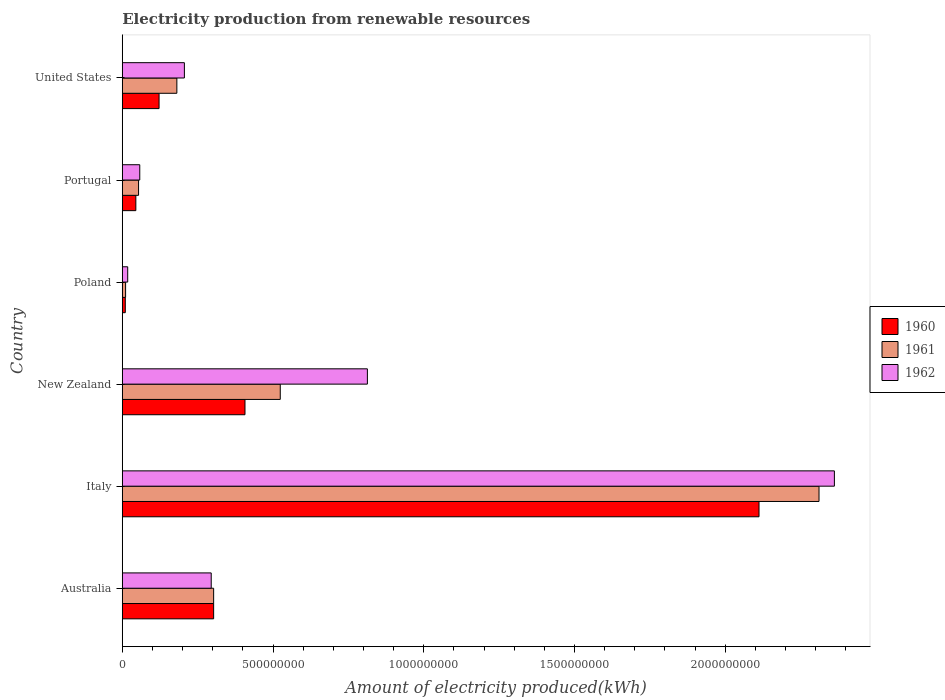How many bars are there on the 5th tick from the top?
Ensure brevity in your answer.  3. How many bars are there on the 4th tick from the bottom?
Provide a succinct answer. 3. Across all countries, what is the maximum amount of electricity produced in 1961?
Your answer should be very brief. 2.31e+09. Across all countries, what is the minimum amount of electricity produced in 1960?
Your answer should be compact. 1.00e+07. In which country was the amount of electricity produced in 1960 maximum?
Provide a succinct answer. Italy. What is the total amount of electricity produced in 1961 in the graph?
Your answer should be very brief. 3.38e+09. What is the difference between the amount of electricity produced in 1962 in Italy and that in New Zealand?
Give a very brief answer. 1.55e+09. What is the difference between the amount of electricity produced in 1962 in Italy and the amount of electricity produced in 1961 in Portugal?
Make the answer very short. 2.31e+09. What is the average amount of electricity produced in 1962 per country?
Your answer should be compact. 6.25e+08. What is the difference between the amount of electricity produced in 1960 and amount of electricity produced in 1961 in Portugal?
Your answer should be compact. -9.00e+06. In how many countries, is the amount of electricity produced in 1962 greater than 100000000 kWh?
Ensure brevity in your answer.  4. What is the ratio of the amount of electricity produced in 1960 in Australia to that in Italy?
Give a very brief answer. 0.14. Is the amount of electricity produced in 1960 in Italy less than that in New Zealand?
Your answer should be compact. No. Is the difference between the amount of electricity produced in 1960 in Italy and Portugal greater than the difference between the amount of electricity produced in 1961 in Italy and Portugal?
Offer a very short reply. No. What is the difference between the highest and the second highest amount of electricity produced in 1960?
Keep it short and to the point. 1.70e+09. What is the difference between the highest and the lowest amount of electricity produced in 1961?
Give a very brief answer. 2.30e+09. Is the sum of the amount of electricity produced in 1960 in Australia and Italy greater than the maximum amount of electricity produced in 1961 across all countries?
Ensure brevity in your answer.  Yes. What does the 2nd bar from the top in Australia represents?
Provide a short and direct response. 1961. Is it the case that in every country, the sum of the amount of electricity produced in 1962 and amount of electricity produced in 1961 is greater than the amount of electricity produced in 1960?
Ensure brevity in your answer.  Yes. Are all the bars in the graph horizontal?
Offer a very short reply. Yes. Does the graph contain any zero values?
Provide a succinct answer. No. Where does the legend appear in the graph?
Your answer should be compact. Center right. What is the title of the graph?
Provide a short and direct response. Electricity production from renewable resources. Does "1977" appear as one of the legend labels in the graph?
Offer a very short reply. No. What is the label or title of the X-axis?
Provide a short and direct response. Amount of electricity produced(kWh). What is the Amount of electricity produced(kWh) of 1960 in Australia?
Your response must be concise. 3.03e+08. What is the Amount of electricity produced(kWh) of 1961 in Australia?
Offer a terse response. 3.03e+08. What is the Amount of electricity produced(kWh) in 1962 in Australia?
Make the answer very short. 2.95e+08. What is the Amount of electricity produced(kWh) of 1960 in Italy?
Provide a succinct answer. 2.11e+09. What is the Amount of electricity produced(kWh) in 1961 in Italy?
Give a very brief answer. 2.31e+09. What is the Amount of electricity produced(kWh) of 1962 in Italy?
Your response must be concise. 2.36e+09. What is the Amount of electricity produced(kWh) of 1960 in New Zealand?
Give a very brief answer. 4.07e+08. What is the Amount of electricity produced(kWh) in 1961 in New Zealand?
Provide a short and direct response. 5.24e+08. What is the Amount of electricity produced(kWh) of 1962 in New Zealand?
Keep it short and to the point. 8.13e+08. What is the Amount of electricity produced(kWh) of 1961 in Poland?
Give a very brief answer. 1.10e+07. What is the Amount of electricity produced(kWh) in 1962 in Poland?
Provide a short and direct response. 1.80e+07. What is the Amount of electricity produced(kWh) of 1960 in Portugal?
Your answer should be very brief. 4.50e+07. What is the Amount of electricity produced(kWh) of 1961 in Portugal?
Your response must be concise. 5.40e+07. What is the Amount of electricity produced(kWh) of 1962 in Portugal?
Your answer should be compact. 5.80e+07. What is the Amount of electricity produced(kWh) of 1960 in United States?
Make the answer very short. 1.22e+08. What is the Amount of electricity produced(kWh) of 1961 in United States?
Give a very brief answer. 1.81e+08. What is the Amount of electricity produced(kWh) of 1962 in United States?
Keep it short and to the point. 2.06e+08. Across all countries, what is the maximum Amount of electricity produced(kWh) of 1960?
Your answer should be compact. 2.11e+09. Across all countries, what is the maximum Amount of electricity produced(kWh) of 1961?
Provide a succinct answer. 2.31e+09. Across all countries, what is the maximum Amount of electricity produced(kWh) in 1962?
Give a very brief answer. 2.36e+09. Across all countries, what is the minimum Amount of electricity produced(kWh) in 1961?
Your response must be concise. 1.10e+07. Across all countries, what is the minimum Amount of electricity produced(kWh) of 1962?
Your answer should be very brief. 1.80e+07. What is the total Amount of electricity produced(kWh) in 1960 in the graph?
Give a very brief answer. 3.00e+09. What is the total Amount of electricity produced(kWh) of 1961 in the graph?
Ensure brevity in your answer.  3.38e+09. What is the total Amount of electricity produced(kWh) of 1962 in the graph?
Give a very brief answer. 3.75e+09. What is the difference between the Amount of electricity produced(kWh) of 1960 in Australia and that in Italy?
Offer a very short reply. -1.81e+09. What is the difference between the Amount of electricity produced(kWh) of 1961 in Australia and that in Italy?
Ensure brevity in your answer.  -2.01e+09. What is the difference between the Amount of electricity produced(kWh) of 1962 in Australia and that in Italy?
Your response must be concise. -2.07e+09. What is the difference between the Amount of electricity produced(kWh) in 1960 in Australia and that in New Zealand?
Keep it short and to the point. -1.04e+08. What is the difference between the Amount of electricity produced(kWh) of 1961 in Australia and that in New Zealand?
Your answer should be compact. -2.21e+08. What is the difference between the Amount of electricity produced(kWh) in 1962 in Australia and that in New Zealand?
Your answer should be compact. -5.18e+08. What is the difference between the Amount of electricity produced(kWh) of 1960 in Australia and that in Poland?
Provide a succinct answer. 2.93e+08. What is the difference between the Amount of electricity produced(kWh) of 1961 in Australia and that in Poland?
Give a very brief answer. 2.92e+08. What is the difference between the Amount of electricity produced(kWh) of 1962 in Australia and that in Poland?
Your answer should be very brief. 2.77e+08. What is the difference between the Amount of electricity produced(kWh) in 1960 in Australia and that in Portugal?
Make the answer very short. 2.58e+08. What is the difference between the Amount of electricity produced(kWh) in 1961 in Australia and that in Portugal?
Provide a succinct answer. 2.49e+08. What is the difference between the Amount of electricity produced(kWh) in 1962 in Australia and that in Portugal?
Offer a very short reply. 2.37e+08. What is the difference between the Amount of electricity produced(kWh) in 1960 in Australia and that in United States?
Your response must be concise. 1.81e+08. What is the difference between the Amount of electricity produced(kWh) in 1961 in Australia and that in United States?
Make the answer very short. 1.22e+08. What is the difference between the Amount of electricity produced(kWh) in 1962 in Australia and that in United States?
Make the answer very short. 8.90e+07. What is the difference between the Amount of electricity produced(kWh) of 1960 in Italy and that in New Zealand?
Provide a short and direct response. 1.70e+09. What is the difference between the Amount of electricity produced(kWh) of 1961 in Italy and that in New Zealand?
Provide a short and direct response. 1.79e+09. What is the difference between the Amount of electricity produced(kWh) in 1962 in Italy and that in New Zealand?
Your answer should be very brief. 1.55e+09. What is the difference between the Amount of electricity produced(kWh) in 1960 in Italy and that in Poland?
Your answer should be compact. 2.10e+09. What is the difference between the Amount of electricity produced(kWh) in 1961 in Italy and that in Poland?
Provide a short and direct response. 2.30e+09. What is the difference between the Amount of electricity produced(kWh) in 1962 in Italy and that in Poland?
Offer a very short reply. 2.34e+09. What is the difference between the Amount of electricity produced(kWh) of 1960 in Italy and that in Portugal?
Offer a very short reply. 2.07e+09. What is the difference between the Amount of electricity produced(kWh) of 1961 in Italy and that in Portugal?
Keep it short and to the point. 2.26e+09. What is the difference between the Amount of electricity produced(kWh) of 1962 in Italy and that in Portugal?
Your response must be concise. 2.30e+09. What is the difference between the Amount of electricity produced(kWh) of 1960 in Italy and that in United States?
Your response must be concise. 1.99e+09. What is the difference between the Amount of electricity produced(kWh) in 1961 in Italy and that in United States?
Offer a terse response. 2.13e+09. What is the difference between the Amount of electricity produced(kWh) of 1962 in Italy and that in United States?
Keep it short and to the point. 2.16e+09. What is the difference between the Amount of electricity produced(kWh) of 1960 in New Zealand and that in Poland?
Ensure brevity in your answer.  3.97e+08. What is the difference between the Amount of electricity produced(kWh) of 1961 in New Zealand and that in Poland?
Keep it short and to the point. 5.13e+08. What is the difference between the Amount of electricity produced(kWh) of 1962 in New Zealand and that in Poland?
Provide a short and direct response. 7.95e+08. What is the difference between the Amount of electricity produced(kWh) in 1960 in New Zealand and that in Portugal?
Your response must be concise. 3.62e+08. What is the difference between the Amount of electricity produced(kWh) of 1961 in New Zealand and that in Portugal?
Provide a succinct answer. 4.70e+08. What is the difference between the Amount of electricity produced(kWh) of 1962 in New Zealand and that in Portugal?
Your answer should be compact. 7.55e+08. What is the difference between the Amount of electricity produced(kWh) of 1960 in New Zealand and that in United States?
Your answer should be very brief. 2.85e+08. What is the difference between the Amount of electricity produced(kWh) in 1961 in New Zealand and that in United States?
Ensure brevity in your answer.  3.43e+08. What is the difference between the Amount of electricity produced(kWh) of 1962 in New Zealand and that in United States?
Offer a terse response. 6.07e+08. What is the difference between the Amount of electricity produced(kWh) of 1960 in Poland and that in Portugal?
Give a very brief answer. -3.50e+07. What is the difference between the Amount of electricity produced(kWh) in 1961 in Poland and that in Portugal?
Offer a terse response. -4.30e+07. What is the difference between the Amount of electricity produced(kWh) of 1962 in Poland and that in Portugal?
Your answer should be compact. -4.00e+07. What is the difference between the Amount of electricity produced(kWh) in 1960 in Poland and that in United States?
Ensure brevity in your answer.  -1.12e+08. What is the difference between the Amount of electricity produced(kWh) of 1961 in Poland and that in United States?
Your answer should be compact. -1.70e+08. What is the difference between the Amount of electricity produced(kWh) of 1962 in Poland and that in United States?
Provide a succinct answer. -1.88e+08. What is the difference between the Amount of electricity produced(kWh) in 1960 in Portugal and that in United States?
Give a very brief answer. -7.70e+07. What is the difference between the Amount of electricity produced(kWh) of 1961 in Portugal and that in United States?
Provide a succinct answer. -1.27e+08. What is the difference between the Amount of electricity produced(kWh) in 1962 in Portugal and that in United States?
Offer a very short reply. -1.48e+08. What is the difference between the Amount of electricity produced(kWh) in 1960 in Australia and the Amount of electricity produced(kWh) in 1961 in Italy?
Make the answer very short. -2.01e+09. What is the difference between the Amount of electricity produced(kWh) of 1960 in Australia and the Amount of electricity produced(kWh) of 1962 in Italy?
Your answer should be very brief. -2.06e+09. What is the difference between the Amount of electricity produced(kWh) of 1961 in Australia and the Amount of electricity produced(kWh) of 1962 in Italy?
Your answer should be compact. -2.06e+09. What is the difference between the Amount of electricity produced(kWh) of 1960 in Australia and the Amount of electricity produced(kWh) of 1961 in New Zealand?
Your answer should be compact. -2.21e+08. What is the difference between the Amount of electricity produced(kWh) in 1960 in Australia and the Amount of electricity produced(kWh) in 1962 in New Zealand?
Provide a short and direct response. -5.10e+08. What is the difference between the Amount of electricity produced(kWh) in 1961 in Australia and the Amount of electricity produced(kWh) in 1962 in New Zealand?
Ensure brevity in your answer.  -5.10e+08. What is the difference between the Amount of electricity produced(kWh) in 1960 in Australia and the Amount of electricity produced(kWh) in 1961 in Poland?
Give a very brief answer. 2.92e+08. What is the difference between the Amount of electricity produced(kWh) in 1960 in Australia and the Amount of electricity produced(kWh) in 1962 in Poland?
Offer a very short reply. 2.85e+08. What is the difference between the Amount of electricity produced(kWh) of 1961 in Australia and the Amount of electricity produced(kWh) of 1962 in Poland?
Provide a succinct answer. 2.85e+08. What is the difference between the Amount of electricity produced(kWh) in 1960 in Australia and the Amount of electricity produced(kWh) in 1961 in Portugal?
Keep it short and to the point. 2.49e+08. What is the difference between the Amount of electricity produced(kWh) of 1960 in Australia and the Amount of electricity produced(kWh) of 1962 in Portugal?
Your answer should be very brief. 2.45e+08. What is the difference between the Amount of electricity produced(kWh) in 1961 in Australia and the Amount of electricity produced(kWh) in 1962 in Portugal?
Offer a very short reply. 2.45e+08. What is the difference between the Amount of electricity produced(kWh) in 1960 in Australia and the Amount of electricity produced(kWh) in 1961 in United States?
Offer a terse response. 1.22e+08. What is the difference between the Amount of electricity produced(kWh) of 1960 in Australia and the Amount of electricity produced(kWh) of 1962 in United States?
Give a very brief answer. 9.70e+07. What is the difference between the Amount of electricity produced(kWh) of 1961 in Australia and the Amount of electricity produced(kWh) of 1962 in United States?
Provide a short and direct response. 9.70e+07. What is the difference between the Amount of electricity produced(kWh) of 1960 in Italy and the Amount of electricity produced(kWh) of 1961 in New Zealand?
Ensure brevity in your answer.  1.59e+09. What is the difference between the Amount of electricity produced(kWh) in 1960 in Italy and the Amount of electricity produced(kWh) in 1962 in New Zealand?
Keep it short and to the point. 1.30e+09. What is the difference between the Amount of electricity produced(kWh) of 1961 in Italy and the Amount of electricity produced(kWh) of 1962 in New Zealand?
Make the answer very short. 1.50e+09. What is the difference between the Amount of electricity produced(kWh) in 1960 in Italy and the Amount of electricity produced(kWh) in 1961 in Poland?
Your answer should be compact. 2.10e+09. What is the difference between the Amount of electricity produced(kWh) of 1960 in Italy and the Amount of electricity produced(kWh) of 1962 in Poland?
Provide a succinct answer. 2.09e+09. What is the difference between the Amount of electricity produced(kWh) of 1961 in Italy and the Amount of electricity produced(kWh) of 1962 in Poland?
Make the answer very short. 2.29e+09. What is the difference between the Amount of electricity produced(kWh) in 1960 in Italy and the Amount of electricity produced(kWh) in 1961 in Portugal?
Give a very brief answer. 2.06e+09. What is the difference between the Amount of electricity produced(kWh) of 1960 in Italy and the Amount of electricity produced(kWh) of 1962 in Portugal?
Ensure brevity in your answer.  2.05e+09. What is the difference between the Amount of electricity produced(kWh) of 1961 in Italy and the Amount of electricity produced(kWh) of 1962 in Portugal?
Your response must be concise. 2.25e+09. What is the difference between the Amount of electricity produced(kWh) of 1960 in Italy and the Amount of electricity produced(kWh) of 1961 in United States?
Give a very brief answer. 1.93e+09. What is the difference between the Amount of electricity produced(kWh) in 1960 in Italy and the Amount of electricity produced(kWh) in 1962 in United States?
Provide a succinct answer. 1.91e+09. What is the difference between the Amount of electricity produced(kWh) in 1961 in Italy and the Amount of electricity produced(kWh) in 1962 in United States?
Your response must be concise. 2.10e+09. What is the difference between the Amount of electricity produced(kWh) in 1960 in New Zealand and the Amount of electricity produced(kWh) in 1961 in Poland?
Keep it short and to the point. 3.96e+08. What is the difference between the Amount of electricity produced(kWh) in 1960 in New Zealand and the Amount of electricity produced(kWh) in 1962 in Poland?
Give a very brief answer. 3.89e+08. What is the difference between the Amount of electricity produced(kWh) of 1961 in New Zealand and the Amount of electricity produced(kWh) of 1962 in Poland?
Your answer should be very brief. 5.06e+08. What is the difference between the Amount of electricity produced(kWh) of 1960 in New Zealand and the Amount of electricity produced(kWh) of 1961 in Portugal?
Make the answer very short. 3.53e+08. What is the difference between the Amount of electricity produced(kWh) of 1960 in New Zealand and the Amount of electricity produced(kWh) of 1962 in Portugal?
Ensure brevity in your answer.  3.49e+08. What is the difference between the Amount of electricity produced(kWh) in 1961 in New Zealand and the Amount of electricity produced(kWh) in 1962 in Portugal?
Your answer should be very brief. 4.66e+08. What is the difference between the Amount of electricity produced(kWh) of 1960 in New Zealand and the Amount of electricity produced(kWh) of 1961 in United States?
Keep it short and to the point. 2.26e+08. What is the difference between the Amount of electricity produced(kWh) in 1960 in New Zealand and the Amount of electricity produced(kWh) in 1962 in United States?
Offer a very short reply. 2.01e+08. What is the difference between the Amount of electricity produced(kWh) of 1961 in New Zealand and the Amount of electricity produced(kWh) of 1962 in United States?
Offer a terse response. 3.18e+08. What is the difference between the Amount of electricity produced(kWh) in 1960 in Poland and the Amount of electricity produced(kWh) in 1961 in Portugal?
Provide a short and direct response. -4.40e+07. What is the difference between the Amount of electricity produced(kWh) in 1960 in Poland and the Amount of electricity produced(kWh) in 1962 in Portugal?
Your response must be concise. -4.80e+07. What is the difference between the Amount of electricity produced(kWh) in 1961 in Poland and the Amount of electricity produced(kWh) in 1962 in Portugal?
Your answer should be compact. -4.70e+07. What is the difference between the Amount of electricity produced(kWh) of 1960 in Poland and the Amount of electricity produced(kWh) of 1961 in United States?
Provide a succinct answer. -1.71e+08. What is the difference between the Amount of electricity produced(kWh) in 1960 in Poland and the Amount of electricity produced(kWh) in 1962 in United States?
Your answer should be compact. -1.96e+08. What is the difference between the Amount of electricity produced(kWh) in 1961 in Poland and the Amount of electricity produced(kWh) in 1962 in United States?
Keep it short and to the point. -1.95e+08. What is the difference between the Amount of electricity produced(kWh) of 1960 in Portugal and the Amount of electricity produced(kWh) of 1961 in United States?
Keep it short and to the point. -1.36e+08. What is the difference between the Amount of electricity produced(kWh) of 1960 in Portugal and the Amount of electricity produced(kWh) of 1962 in United States?
Keep it short and to the point. -1.61e+08. What is the difference between the Amount of electricity produced(kWh) of 1961 in Portugal and the Amount of electricity produced(kWh) of 1962 in United States?
Provide a succinct answer. -1.52e+08. What is the average Amount of electricity produced(kWh) in 1960 per country?
Provide a short and direct response. 5.00e+08. What is the average Amount of electricity produced(kWh) of 1961 per country?
Offer a terse response. 5.64e+08. What is the average Amount of electricity produced(kWh) in 1962 per country?
Provide a succinct answer. 6.25e+08. What is the difference between the Amount of electricity produced(kWh) of 1960 and Amount of electricity produced(kWh) of 1962 in Australia?
Offer a terse response. 8.00e+06. What is the difference between the Amount of electricity produced(kWh) in 1960 and Amount of electricity produced(kWh) in 1961 in Italy?
Offer a very short reply. -1.99e+08. What is the difference between the Amount of electricity produced(kWh) in 1960 and Amount of electricity produced(kWh) in 1962 in Italy?
Offer a very short reply. -2.50e+08. What is the difference between the Amount of electricity produced(kWh) in 1961 and Amount of electricity produced(kWh) in 1962 in Italy?
Provide a succinct answer. -5.10e+07. What is the difference between the Amount of electricity produced(kWh) of 1960 and Amount of electricity produced(kWh) of 1961 in New Zealand?
Make the answer very short. -1.17e+08. What is the difference between the Amount of electricity produced(kWh) of 1960 and Amount of electricity produced(kWh) of 1962 in New Zealand?
Your answer should be compact. -4.06e+08. What is the difference between the Amount of electricity produced(kWh) in 1961 and Amount of electricity produced(kWh) in 1962 in New Zealand?
Give a very brief answer. -2.89e+08. What is the difference between the Amount of electricity produced(kWh) in 1960 and Amount of electricity produced(kWh) in 1961 in Poland?
Your response must be concise. -1.00e+06. What is the difference between the Amount of electricity produced(kWh) of 1960 and Amount of electricity produced(kWh) of 1962 in Poland?
Your answer should be very brief. -8.00e+06. What is the difference between the Amount of electricity produced(kWh) in 1961 and Amount of electricity produced(kWh) in 1962 in Poland?
Offer a terse response. -7.00e+06. What is the difference between the Amount of electricity produced(kWh) of 1960 and Amount of electricity produced(kWh) of 1961 in Portugal?
Your answer should be very brief. -9.00e+06. What is the difference between the Amount of electricity produced(kWh) in 1960 and Amount of electricity produced(kWh) in 1962 in Portugal?
Offer a very short reply. -1.30e+07. What is the difference between the Amount of electricity produced(kWh) of 1960 and Amount of electricity produced(kWh) of 1961 in United States?
Provide a succinct answer. -5.90e+07. What is the difference between the Amount of electricity produced(kWh) in 1960 and Amount of electricity produced(kWh) in 1962 in United States?
Provide a succinct answer. -8.40e+07. What is the difference between the Amount of electricity produced(kWh) of 1961 and Amount of electricity produced(kWh) of 1962 in United States?
Ensure brevity in your answer.  -2.50e+07. What is the ratio of the Amount of electricity produced(kWh) in 1960 in Australia to that in Italy?
Ensure brevity in your answer.  0.14. What is the ratio of the Amount of electricity produced(kWh) in 1961 in Australia to that in Italy?
Your answer should be compact. 0.13. What is the ratio of the Amount of electricity produced(kWh) of 1962 in Australia to that in Italy?
Ensure brevity in your answer.  0.12. What is the ratio of the Amount of electricity produced(kWh) of 1960 in Australia to that in New Zealand?
Offer a very short reply. 0.74. What is the ratio of the Amount of electricity produced(kWh) in 1961 in Australia to that in New Zealand?
Offer a very short reply. 0.58. What is the ratio of the Amount of electricity produced(kWh) in 1962 in Australia to that in New Zealand?
Keep it short and to the point. 0.36. What is the ratio of the Amount of electricity produced(kWh) in 1960 in Australia to that in Poland?
Ensure brevity in your answer.  30.3. What is the ratio of the Amount of electricity produced(kWh) of 1961 in Australia to that in Poland?
Offer a terse response. 27.55. What is the ratio of the Amount of electricity produced(kWh) in 1962 in Australia to that in Poland?
Offer a terse response. 16.39. What is the ratio of the Amount of electricity produced(kWh) in 1960 in Australia to that in Portugal?
Offer a terse response. 6.73. What is the ratio of the Amount of electricity produced(kWh) in 1961 in Australia to that in Portugal?
Ensure brevity in your answer.  5.61. What is the ratio of the Amount of electricity produced(kWh) of 1962 in Australia to that in Portugal?
Your response must be concise. 5.09. What is the ratio of the Amount of electricity produced(kWh) of 1960 in Australia to that in United States?
Give a very brief answer. 2.48. What is the ratio of the Amount of electricity produced(kWh) of 1961 in Australia to that in United States?
Provide a succinct answer. 1.67. What is the ratio of the Amount of electricity produced(kWh) of 1962 in Australia to that in United States?
Provide a short and direct response. 1.43. What is the ratio of the Amount of electricity produced(kWh) of 1960 in Italy to that in New Zealand?
Your response must be concise. 5.19. What is the ratio of the Amount of electricity produced(kWh) of 1961 in Italy to that in New Zealand?
Your response must be concise. 4.41. What is the ratio of the Amount of electricity produced(kWh) of 1962 in Italy to that in New Zealand?
Keep it short and to the point. 2.91. What is the ratio of the Amount of electricity produced(kWh) in 1960 in Italy to that in Poland?
Keep it short and to the point. 211.2. What is the ratio of the Amount of electricity produced(kWh) of 1961 in Italy to that in Poland?
Ensure brevity in your answer.  210.09. What is the ratio of the Amount of electricity produced(kWh) in 1962 in Italy to that in Poland?
Your answer should be compact. 131.22. What is the ratio of the Amount of electricity produced(kWh) in 1960 in Italy to that in Portugal?
Offer a very short reply. 46.93. What is the ratio of the Amount of electricity produced(kWh) of 1961 in Italy to that in Portugal?
Make the answer very short. 42.8. What is the ratio of the Amount of electricity produced(kWh) of 1962 in Italy to that in Portugal?
Ensure brevity in your answer.  40.72. What is the ratio of the Amount of electricity produced(kWh) in 1960 in Italy to that in United States?
Your answer should be very brief. 17.31. What is the ratio of the Amount of electricity produced(kWh) in 1961 in Italy to that in United States?
Provide a short and direct response. 12.77. What is the ratio of the Amount of electricity produced(kWh) of 1962 in Italy to that in United States?
Give a very brief answer. 11.47. What is the ratio of the Amount of electricity produced(kWh) in 1960 in New Zealand to that in Poland?
Make the answer very short. 40.7. What is the ratio of the Amount of electricity produced(kWh) in 1961 in New Zealand to that in Poland?
Offer a terse response. 47.64. What is the ratio of the Amount of electricity produced(kWh) in 1962 in New Zealand to that in Poland?
Your answer should be very brief. 45.17. What is the ratio of the Amount of electricity produced(kWh) of 1960 in New Zealand to that in Portugal?
Offer a terse response. 9.04. What is the ratio of the Amount of electricity produced(kWh) in 1961 in New Zealand to that in Portugal?
Give a very brief answer. 9.7. What is the ratio of the Amount of electricity produced(kWh) in 1962 in New Zealand to that in Portugal?
Offer a terse response. 14.02. What is the ratio of the Amount of electricity produced(kWh) of 1960 in New Zealand to that in United States?
Offer a very short reply. 3.34. What is the ratio of the Amount of electricity produced(kWh) in 1961 in New Zealand to that in United States?
Provide a short and direct response. 2.9. What is the ratio of the Amount of electricity produced(kWh) of 1962 in New Zealand to that in United States?
Offer a very short reply. 3.95. What is the ratio of the Amount of electricity produced(kWh) in 1960 in Poland to that in Portugal?
Give a very brief answer. 0.22. What is the ratio of the Amount of electricity produced(kWh) of 1961 in Poland to that in Portugal?
Your response must be concise. 0.2. What is the ratio of the Amount of electricity produced(kWh) of 1962 in Poland to that in Portugal?
Your response must be concise. 0.31. What is the ratio of the Amount of electricity produced(kWh) of 1960 in Poland to that in United States?
Ensure brevity in your answer.  0.08. What is the ratio of the Amount of electricity produced(kWh) in 1961 in Poland to that in United States?
Give a very brief answer. 0.06. What is the ratio of the Amount of electricity produced(kWh) in 1962 in Poland to that in United States?
Offer a terse response. 0.09. What is the ratio of the Amount of electricity produced(kWh) in 1960 in Portugal to that in United States?
Ensure brevity in your answer.  0.37. What is the ratio of the Amount of electricity produced(kWh) in 1961 in Portugal to that in United States?
Ensure brevity in your answer.  0.3. What is the ratio of the Amount of electricity produced(kWh) of 1962 in Portugal to that in United States?
Make the answer very short. 0.28. What is the difference between the highest and the second highest Amount of electricity produced(kWh) in 1960?
Ensure brevity in your answer.  1.70e+09. What is the difference between the highest and the second highest Amount of electricity produced(kWh) of 1961?
Your answer should be very brief. 1.79e+09. What is the difference between the highest and the second highest Amount of electricity produced(kWh) of 1962?
Your response must be concise. 1.55e+09. What is the difference between the highest and the lowest Amount of electricity produced(kWh) in 1960?
Your response must be concise. 2.10e+09. What is the difference between the highest and the lowest Amount of electricity produced(kWh) of 1961?
Your answer should be compact. 2.30e+09. What is the difference between the highest and the lowest Amount of electricity produced(kWh) in 1962?
Make the answer very short. 2.34e+09. 